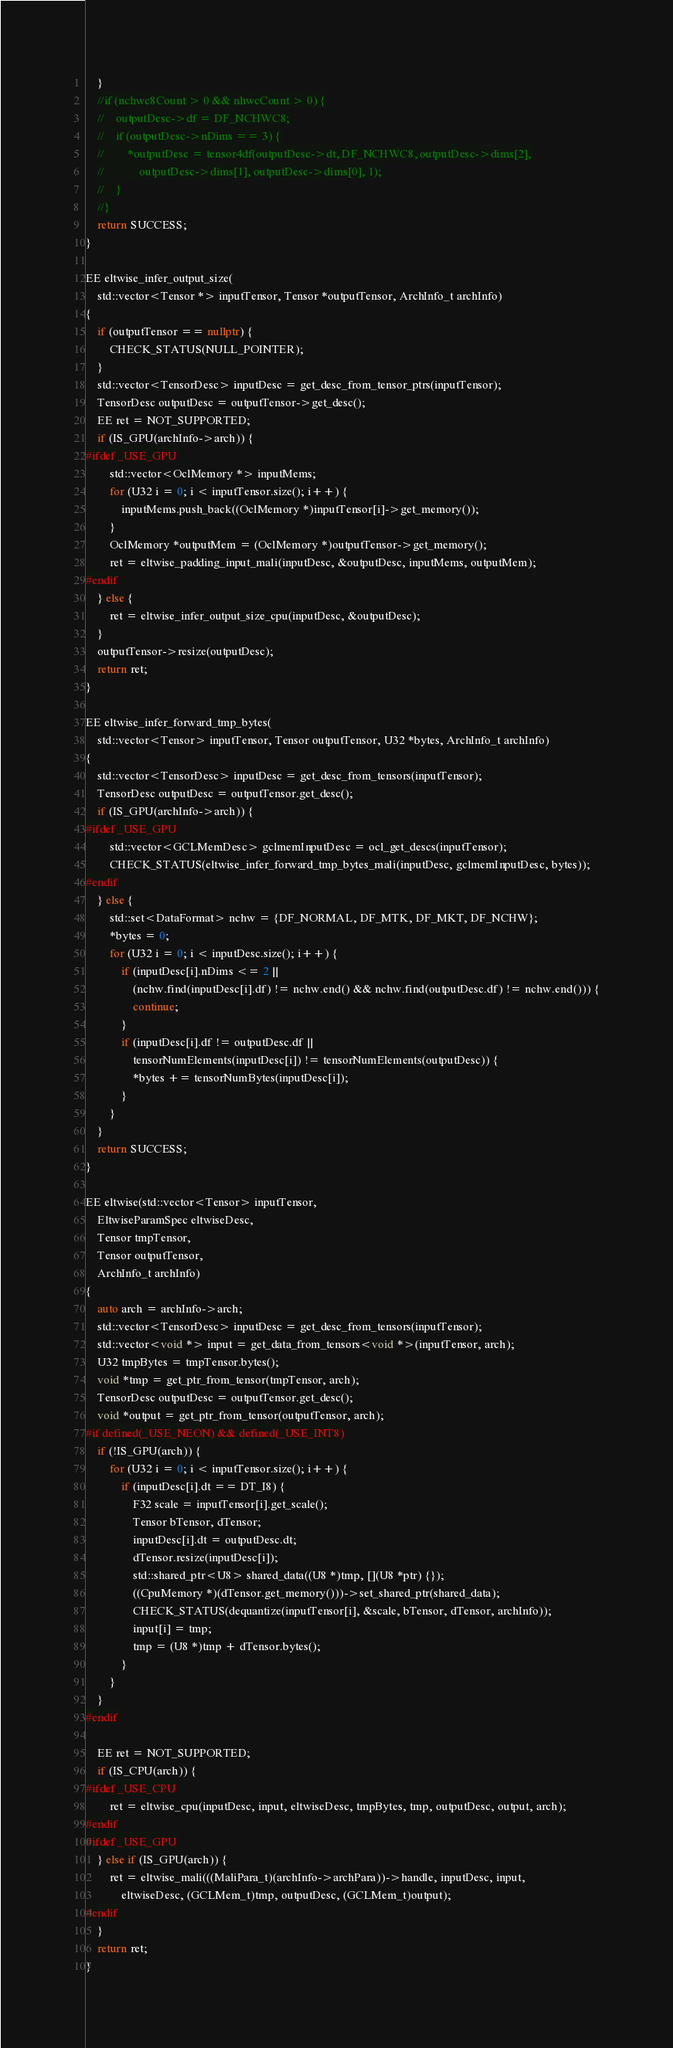Convert code to text. <code><loc_0><loc_0><loc_500><loc_500><_C++_>    }
    //if (nchwc8Count > 0 && nhwcCount > 0) {
    //    outputDesc->df = DF_NCHWC8;
    //    if (outputDesc->nDims == 3) {
    //        *outputDesc = tensor4df(outputDesc->dt, DF_NCHWC8, outputDesc->dims[2],
    //            outputDesc->dims[1], outputDesc->dims[0], 1);
    //    }
    //}
    return SUCCESS;
}

EE eltwise_infer_output_size(
    std::vector<Tensor *> inputTensor, Tensor *outputTensor, ArchInfo_t archInfo)
{
    if (outputTensor == nullptr) {
        CHECK_STATUS(NULL_POINTER);
    }
    std::vector<TensorDesc> inputDesc = get_desc_from_tensor_ptrs(inputTensor);
    TensorDesc outputDesc = outputTensor->get_desc();
    EE ret = NOT_SUPPORTED;
    if (IS_GPU(archInfo->arch)) {
#ifdef _USE_GPU
        std::vector<OclMemory *> inputMems;
        for (U32 i = 0; i < inputTensor.size(); i++) {
            inputMems.push_back((OclMemory *)inputTensor[i]->get_memory());
        }
        OclMemory *outputMem = (OclMemory *)outputTensor->get_memory();
        ret = eltwise_padding_input_mali(inputDesc, &outputDesc, inputMems, outputMem);
#endif
    } else {
        ret = eltwise_infer_output_size_cpu(inputDesc, &outputDesc);
    }
    outputTensor->resize(outputDesc);
    return ret;
}

EE eltwise_infer_forward_tmp_bytes(
    std::vector<Tensor> inputTensor, Tensor outputTensor, U32 *bytes, ArchInfo_t archInfo)
{
    std::vector<TensorDesc> inputDesc = get_desc_from_tensors(inputTensor);
    TensorDesc outputDesc = outputTensor.get_desc();
    if (IS_GPU(archInfo->arch)) {
#ifdef _USE_GPU
        std::vector<GCLMemDesc> gclmemInputDesc = ocl_get_descs(inputTensor);
        CHECK_STATUS(eltwise_infer_forward_tmp_bytes_mali(inputDesc, gclmemInputDesc, bytes));
#endif
    } else {
        std::set<DataFormat> nchw = {DF_NORMAL, DF_MTK, DF_MKT, DF_NCHW};
        *bytes = 0;
        for (U32 i = 0; i < inputDesc.size(); i++) {
            if (inputDesc[i].nDims <= 2 ||
                (nchw.find(inputDesc[i].df) != nchw.end() && nchw.find(outputDesc.df) != nchw.end())) {
                continue;
            }
            if (inputDesc[i].df != outputDesc.df ||
                tensorNumElements(inputDesc[i]) != tensorNumElements(outputDesc)) {
                *bytes += tensorNumBytes(inputDesc[i]);
            }
        }
    }
    return SUCCESS;
}

EE eltwise(std::vector<Tensor> inputTensor,
    EltwiseParamSpec eltwiseDesc,
    Tensor tmpTensor,
    Tensor outputTensor,
    ArchInfo_t archInfo)
{
    auto arch = archInfo->arch;
    std::vector<TensorDesc> inputDesc = get_desc_from_tensors(inputTensor);
    std::vector<void *> input = get_data_from_tensors<void *>(inputTensor, arch);
    U32 tmpBytes = tmpTensor.bytes();
    void *tmp = get_ptr_from_tensor(tmpTensor, arch);
    TensorDesc outputDesc = outputTensor.get_desc();
    void *output = get_ptr_from_tensor(outputTensor, arch);
#if defined(_USE_NEON) && defined(_USE_INT8)
    if (!IS_GPU(arch)) {
        for (U32 i = 0; i < inputTensor.size(); i++) {
            if (inputDesc[i].dt == DT_I8) {
                F32 scale = inputTensor[i].get_scale();
                Tensor bTensor, dTensor;
                inputDesc[i].dt = outputDesc.dt;
                dTensor.resize(inputDesc[i]);
                std::shared_ptr<U8> shared_data((U8 *)tmp, [](U8 *ptr) {});
                ((CpuMemory *)(dTensor.get_memory()))->set_shared_ptr(shared_data);
                CHECK_STATUS(dequantize(inputTensor[i], &scale, bTensor, dTensor, archInfo));
                input[i] = tmp;
                tmp = (U8 *)tmp + dTensor.bytes();
            }
        }
    }
#endif

    EE ret = NOT_SUPPORTED;
    if (IS_CPU(arch)) {
#ifdef _USE_CPU
        ret = eltwise_cpu(inputDesc, input, eltwiseDesc, tmpBytes, tmp, outputDesc, output, arch);
#endif
#ifdef _USE_GPU
    } else if (IS_GPU(arch)) {
        ret = eltwise_mali(((MaliPara_t)(archInfo->archPara))->handle, inputDesc, input,
            eltwiseDesc, (GCLMem_t)tmp, outputDesc, (GCLMem_t)output);
#endif
    }
    return ret;
}
</code> 